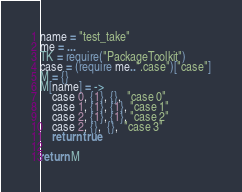Convert code to text. <code><loc_0><loc_0><loc_500><loc_500><_MoonScript_>name = "test_take"
me = ...
TK = require("PackageToolkit")
case = (require me..".case")["case"]
M = {}
M[name] = -> 
    case 0, {1}, {},  "case 0"
    case 1, {1}, {1}, "case 1"
    case 2, {1}, {1}, "case 2"
    case 2, {},  {},  "case 3"
    return true

return M</code> 